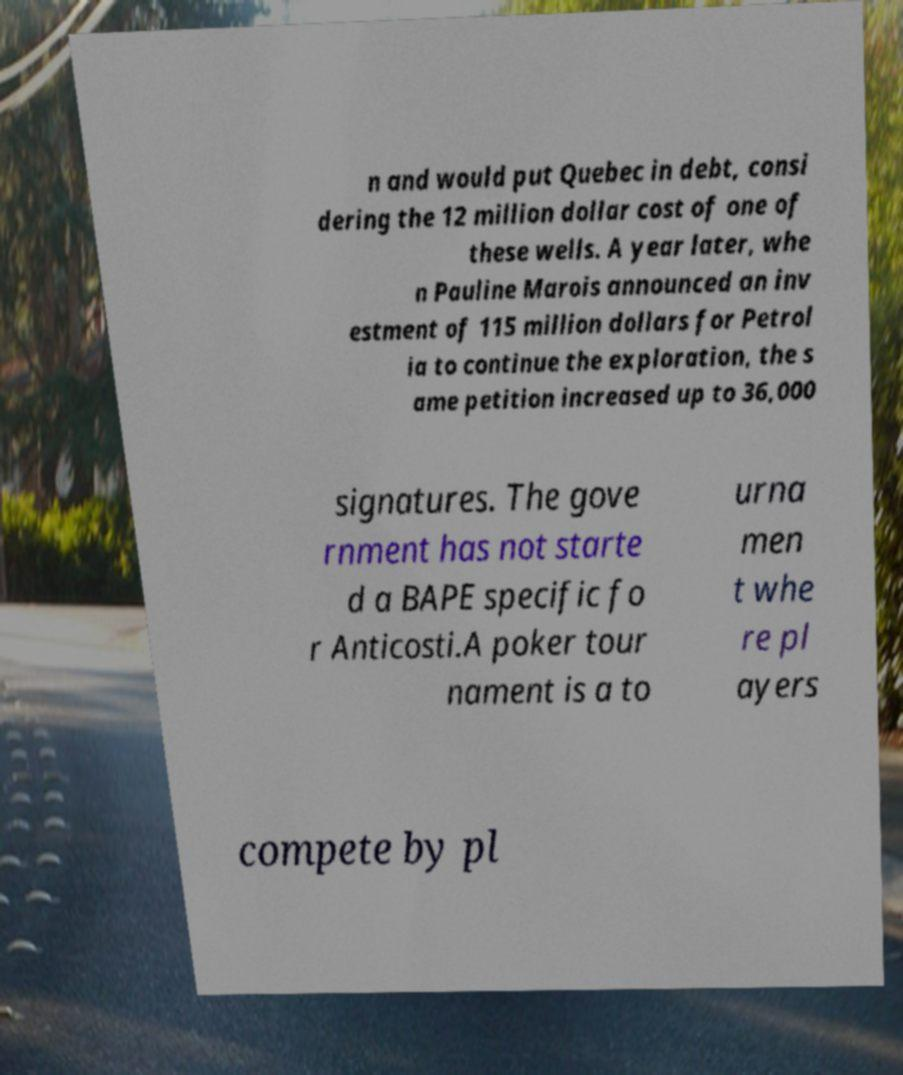Could you assist in decoding the text presented in this image and type it out clearly? n and would put Quebec in debt, consi dering the 12 million dollar cost of one of these wells. A year later, whe n Pauline Marois announced an inv estment of 115 million dollars for Petrol ia to continue the exploration, the s ame petition increased up to 36,000 signatures. The gove rnment has not starte d a BAPE specific fo r Anticosti.A poker tour nament is a to urna men t whe re pl ayers compete by pl 